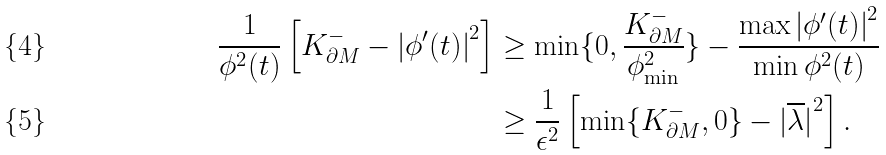<formula> <loc_0><loc_0><loc_500><loc_500>\frac { 1 } { { \phi } ^ { 2 } ( t ) } \left [ K _ { \partial M } ^ { - } - { | \phi ^ { \prime } ( t ) | } ^ { 2 } \right ] & \geq \min \{ 0 , \frac { K _ { \partial M } ^ { - } } { { \phi } _ { \min } ^ { 2 } } \} - \frac { \max { | \phi ^ { \prime } ( t ) | } ^ { 2 } } { \min { \phi } ^ { 2 } ( t ) } \\ & \geq \frac { 1 } { { \epsilon } ^ { 2 } } \left [ \min \{ K _ { \partial M } ^ { - } , 0 \} - { | \overline { \lambda } | } ^ { 2 } \right ] .</formula> 